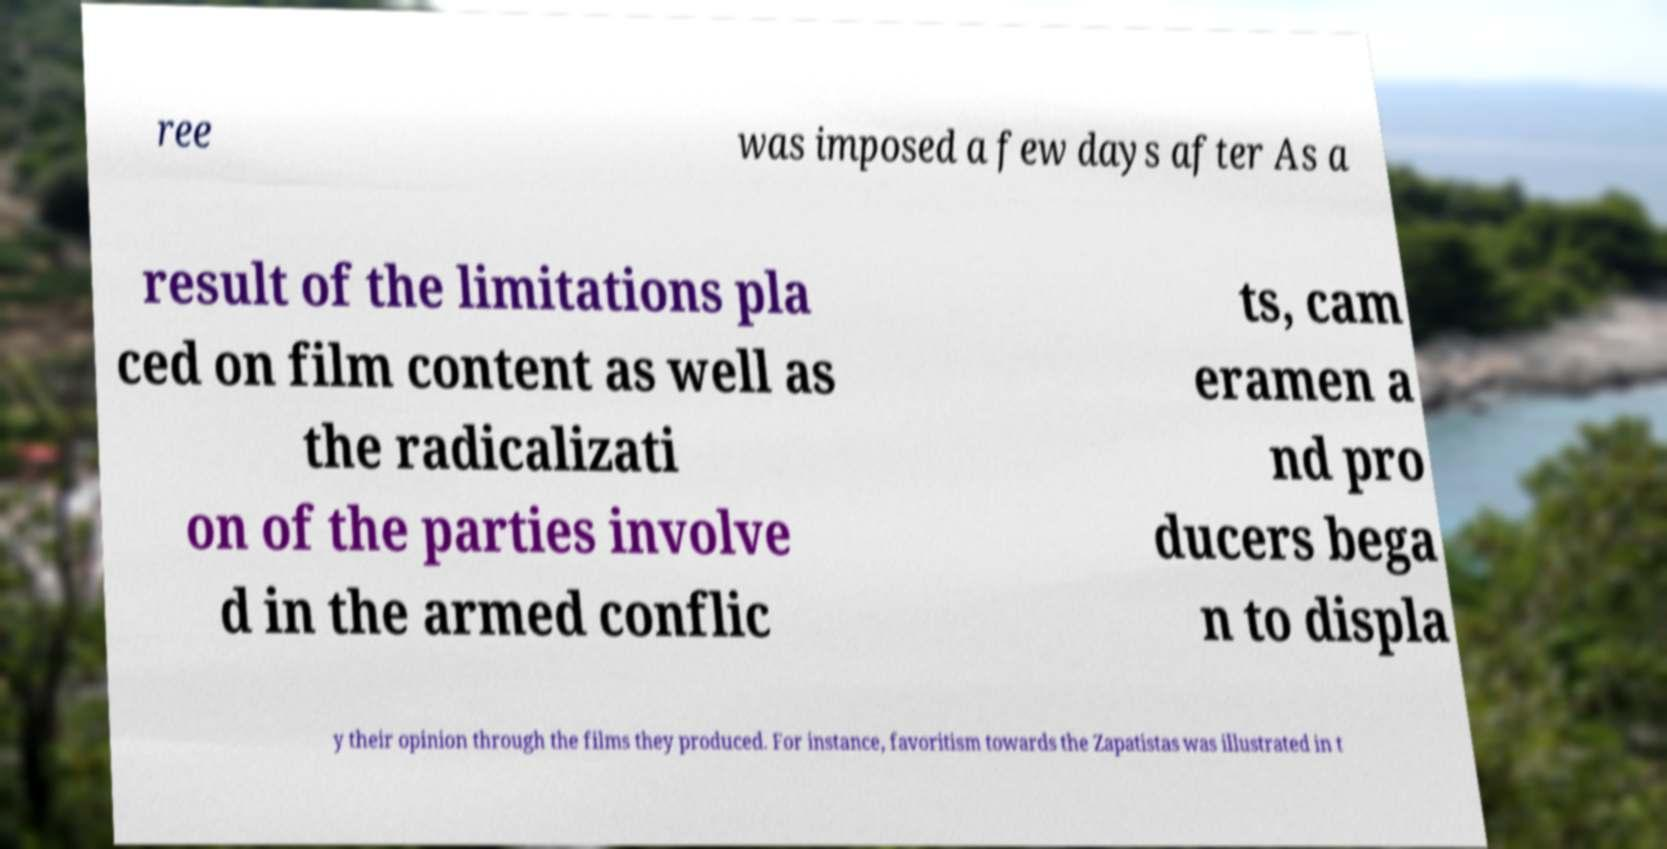What messages or text are displayed in this image? I need them in a readable, typed format. ree was imposed a few days after As a result of the limitations pla ced on film content as well as the radicalizati on of the parties involve d in the armed conflic ts, cam eramen a nd pro ducers bega n to displa y their opinion through the films they produced. For instance, favoritism towards the Zapatistas was illustrated in t 